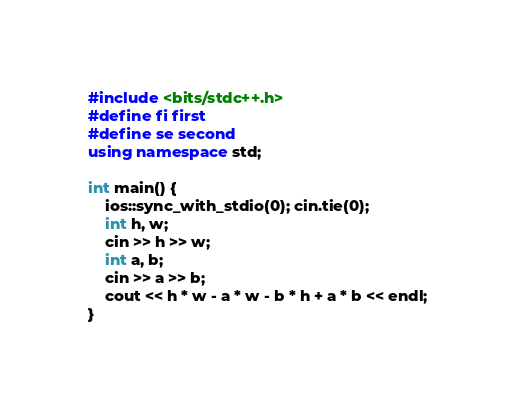<code> <loc_0><loc_0><loc_500><loc_500><_C++_>#include <bits/stdc++.h>
#define fi first
#define se second
using namespace std;

int main() {
    ios::sync_with_stdio(0); cin.tie(0);
    int h, w;
    cin >> h >> w;
    int a, b;
    cin >> a >> b;
    cout << h * w - a * w - b * h + a * b << endl;   
}</code> 